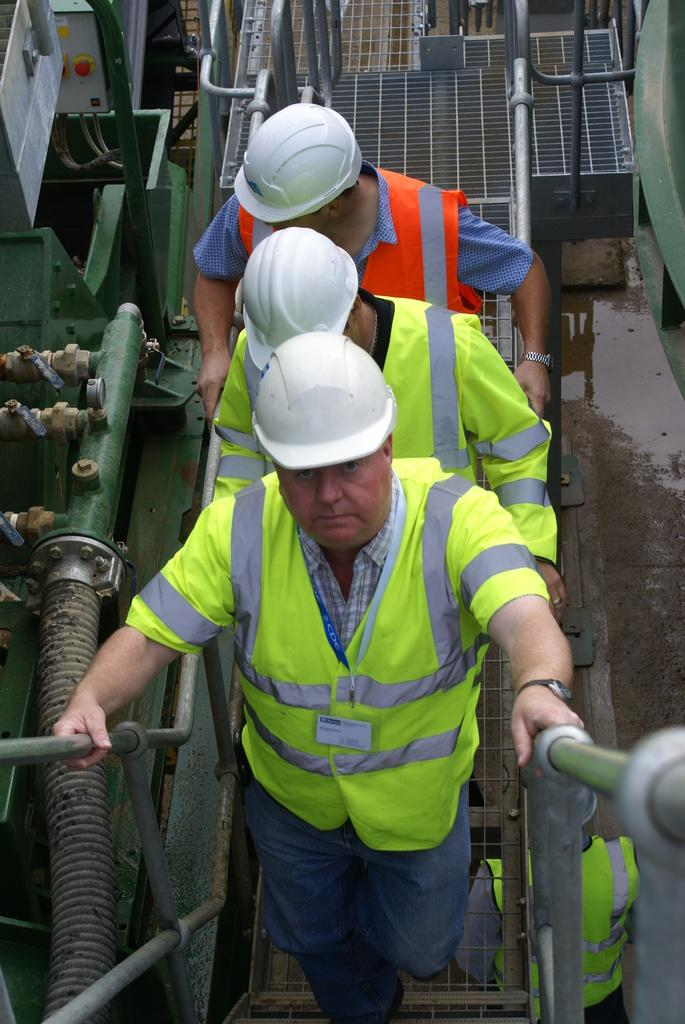What are the people in the image doing? The people in the image are walking. What are the people holding onto while walking? The people are holding onto a railing. What type of material can be seen in the image? There are metal pipes visible in the image. What is the condition of the road in the image? There is no road present in the image; it features people walking and holding onto a railing, with metal pipes visible. How many leaves can be seen on the ground in the image? There are no leaves visible in the image. 